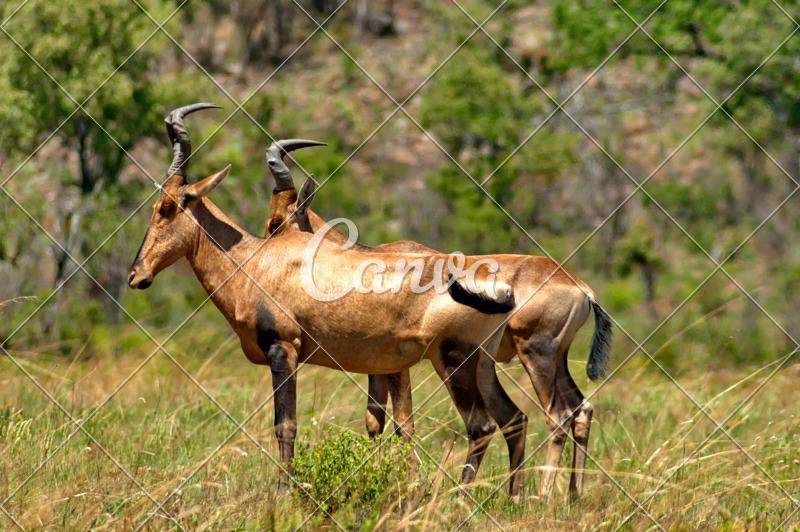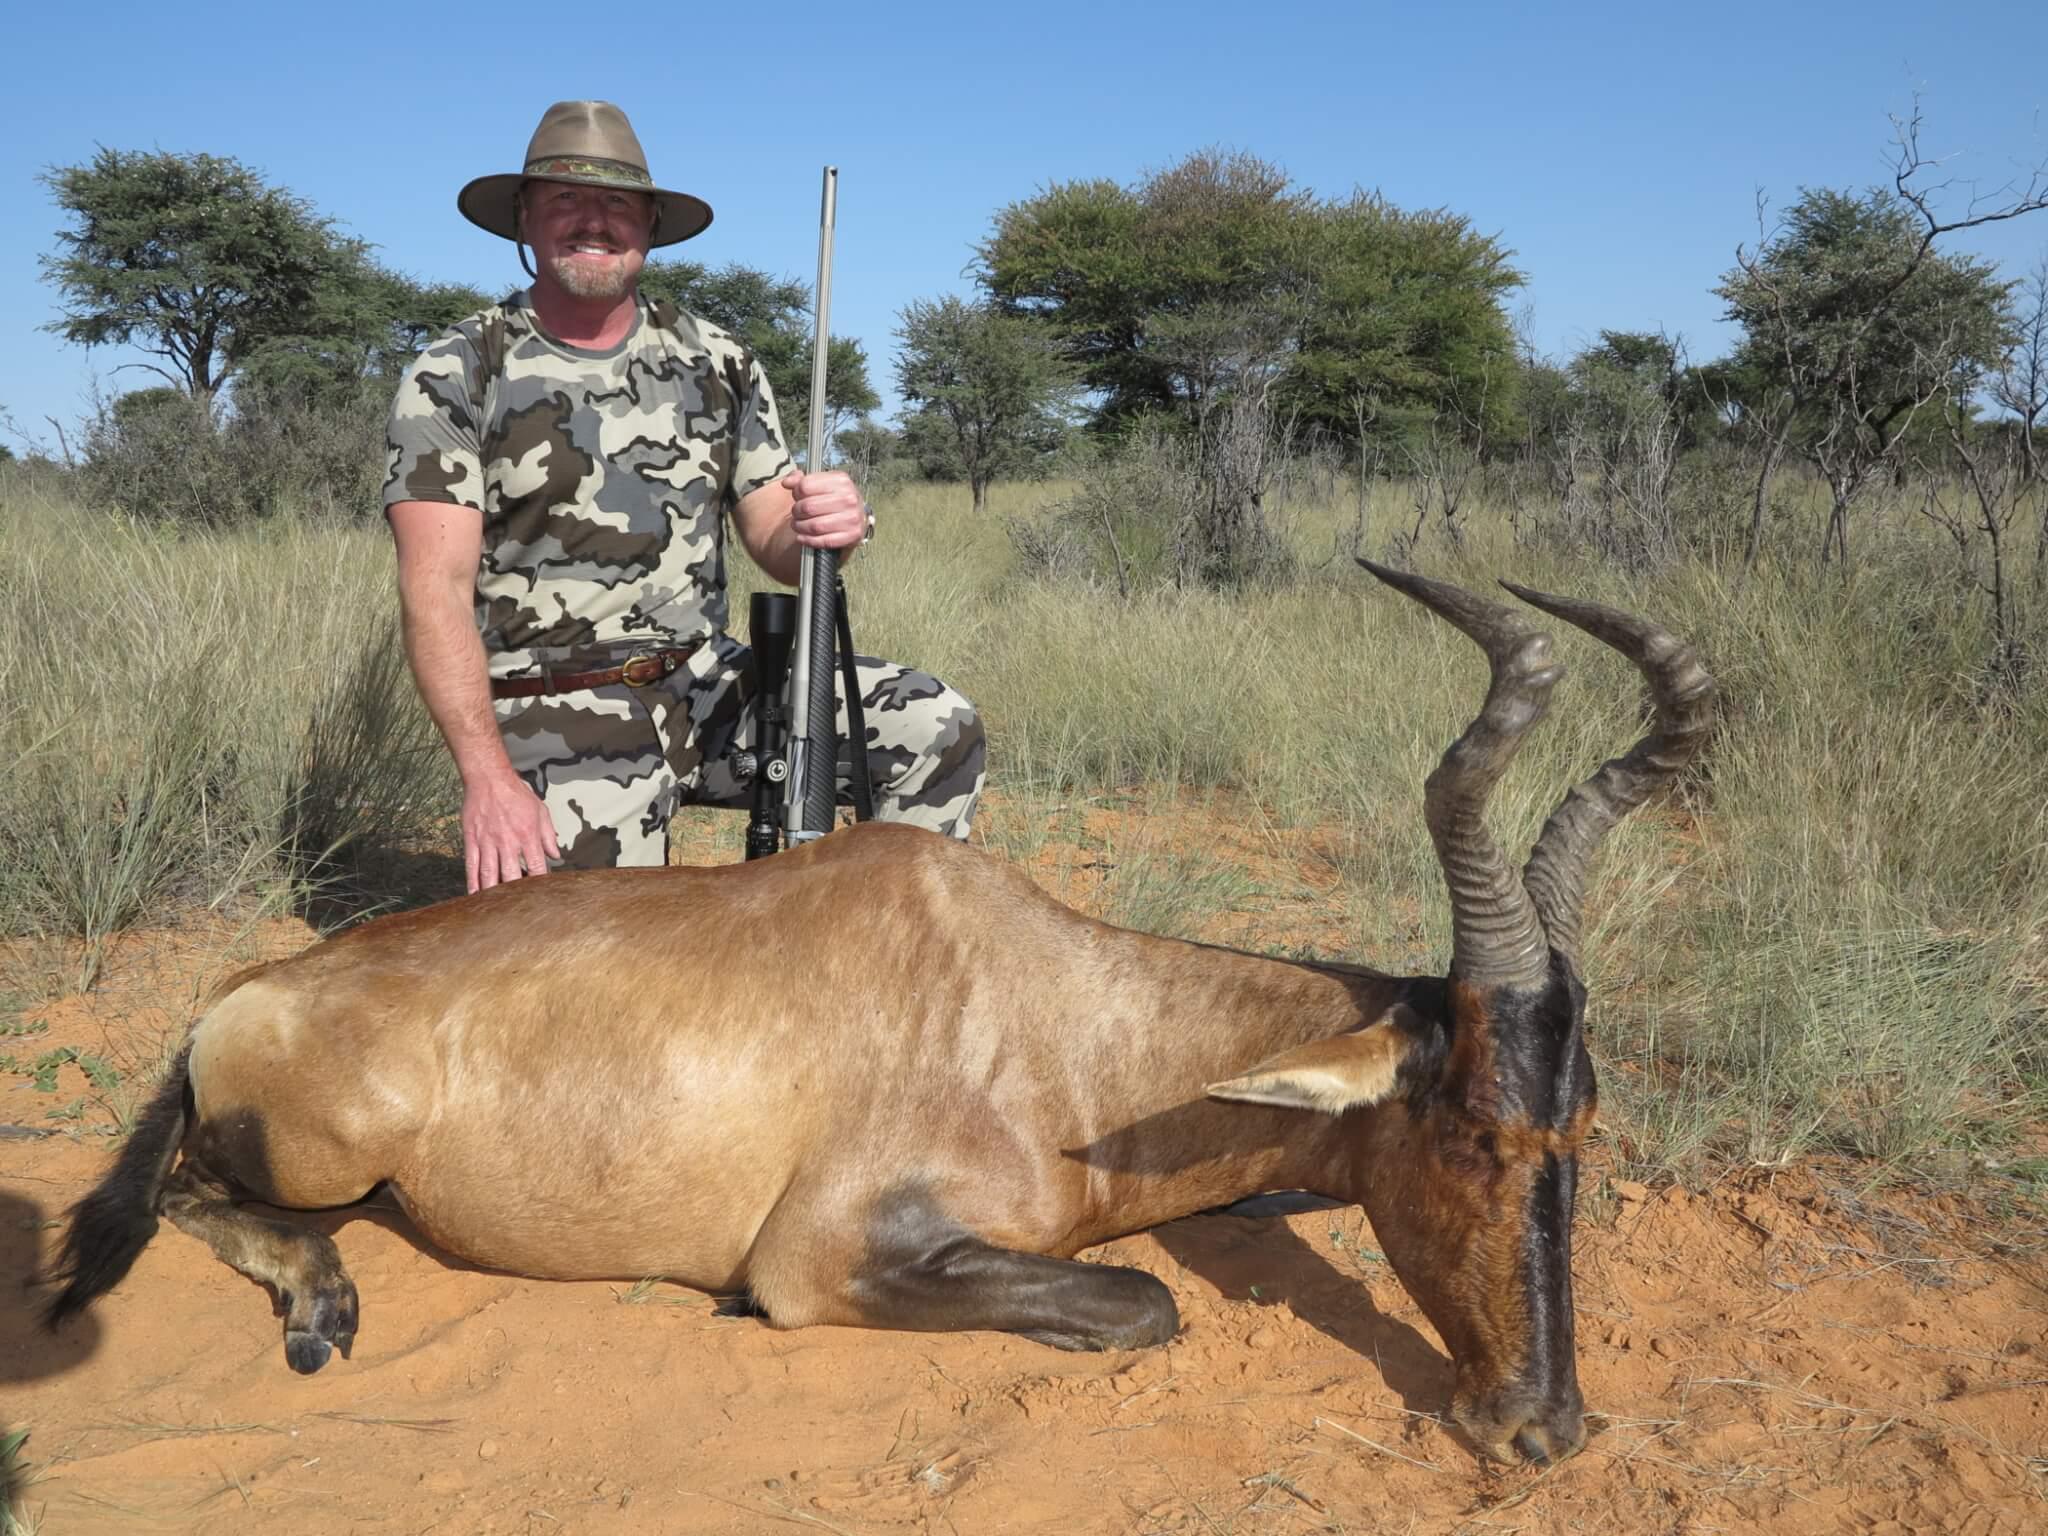The first image is the image on the left, the second image is the image on the right. Assess this claim about the two images: "One of the images shows a mommy and a baby animal together, but not touching.". Correct or not? Answer yes or no. No. The first image is the image on the left, the second image is the image on the right. Considering the images on both sides, is "Exactly two animals are standing." valid? Answer yes or no. Yes. 